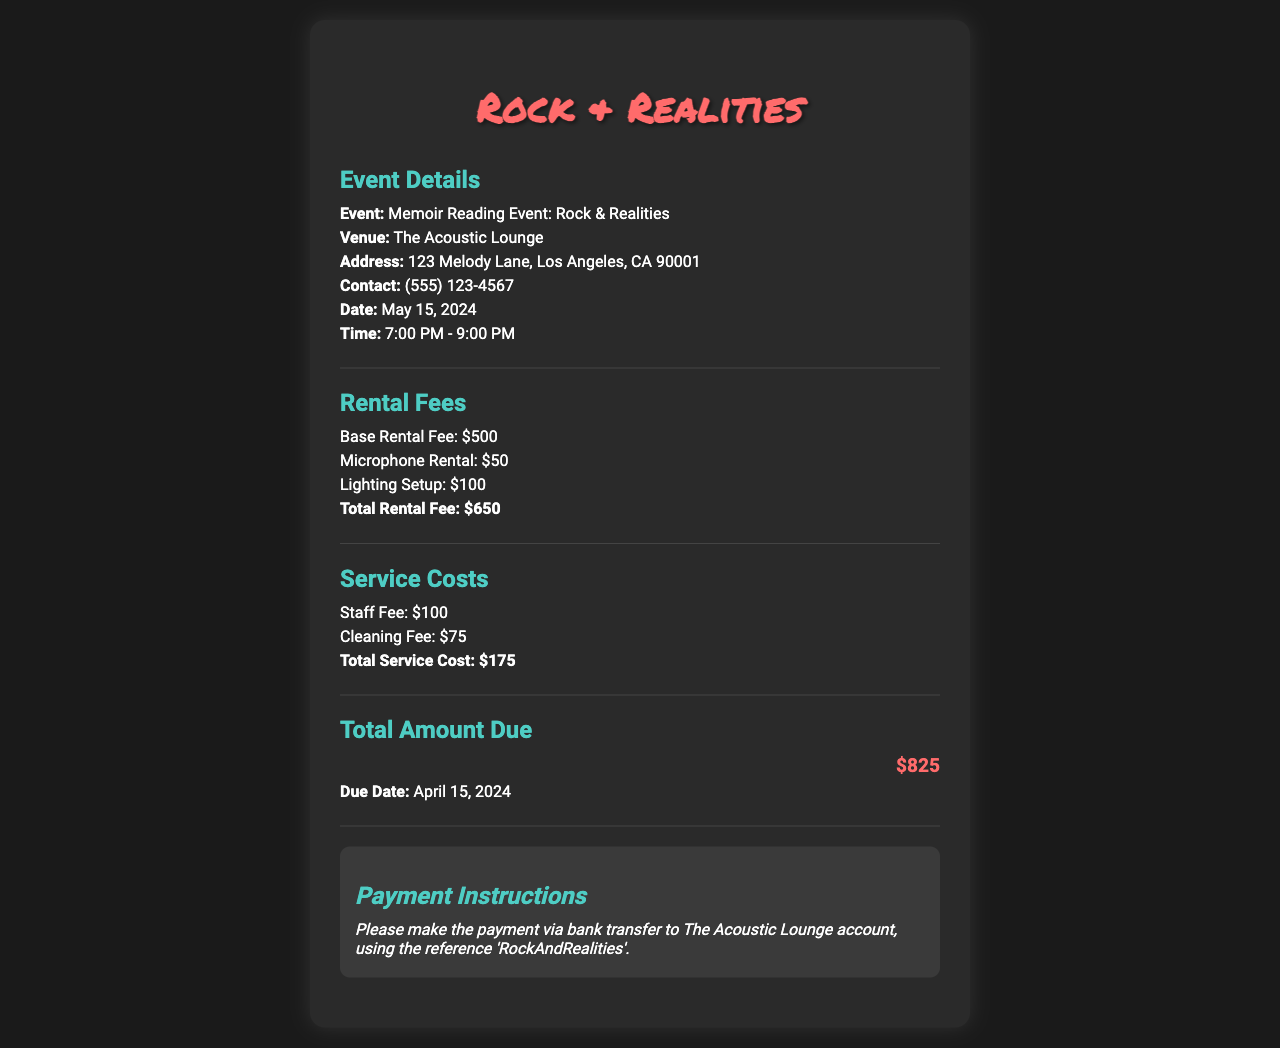What is the event title? The event title is specified at the beginning of the Event Details section of the document.
Answer: Memoir Reading Event: Rock & Realities Where is the venue located? The venue address is mentioned under Event Details in the document.
Answer: 123 Melody Lane, Los Angeles, CA 90001 What is the total rental fee? The total rental fee is provided in the Rental Fees section, which sums the base and additional fees.
Answer: $650 What is the cleaning fee? The cleaning fee is indicated in the Service Costs section of the document.
Answer: $75 What is the total amount due? The total amount due is stated in the Total Amount Due section of the document.
Answer: $825 What is the payment due date? The due date for payment is mentioned in the Total Amount Due section.
Answer: April 15, 2024 What time does the event start? The event start time is listed in the Event Details section.
Answer: 7:00 PM What type of event is being held? The type of event is indicated in the title of the event in the document.
Answer: Memoir Reading Event What is included in the Service Costs? The Service Costs section outlines specific fees included in this grouping.
Answer: Staff Fee and Cleaning Fee 